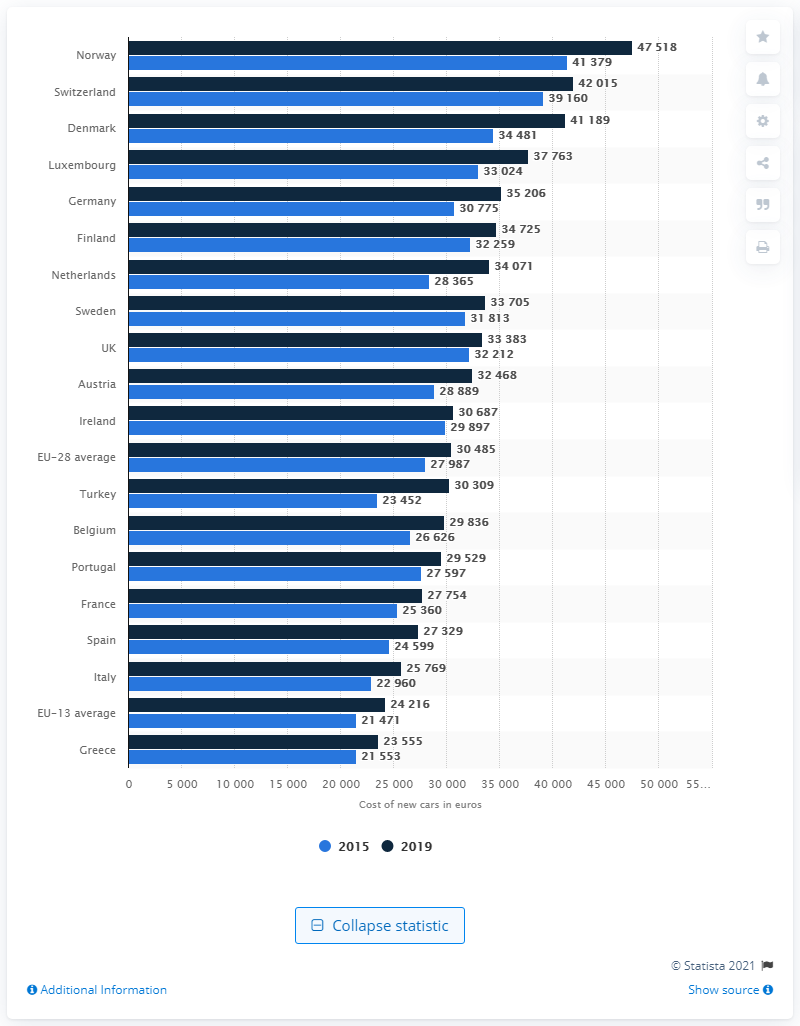Point out several critical features in this image. In 2019, Norway had the highest prices on new passenger cars sold compared to other countries. Norway is the country where electric cars are the most popular among European countries. 